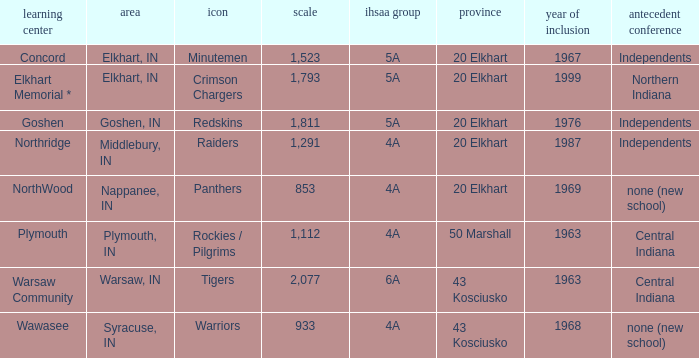What country joined before 1976, with IHSSA class of 5a, and a size larger than 1,112? 20 Elkhart. 